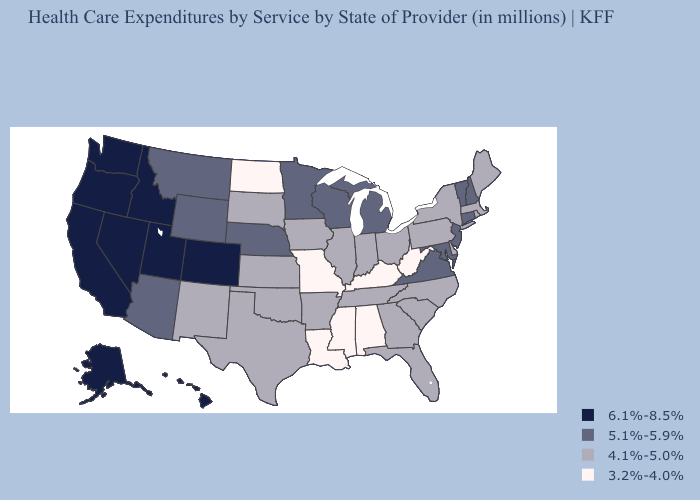Does Hawaii have a higher value than Washington?
Concise answer only. No. Among the states that border Minnesota , does South Dakota have the highest value?
Keep it brief. No. Name the states that have a value in the range 5.1%-5.9%?
Give a very brief answer. Arizona, Connecticut, Maryland, Michigan, Minnesota, Montana, Nebraska, New Hampshire, New Jersey, Vermont, Virginia, Wisconsin, Wyoming. Which states have the lowest value in the USA?
Concise answer only. Alabama, Kentucky, Louisiana, Mississippi, Missouri, North Dakota, West Virginia. What is the highest value in states that border Pennsylvania?
Short answer required. 5.1%-5.9%. Does the first symbol in the legend represent the smallest category?
Give a very brief answer. No. Among the states that border Maryland , does Virginia have the highest value?
Be succinct. Yes. What is the value of Alaska?
Short answer required. 6.1%-8.5%. Name the states that have a value in the range 4.1%-5.0%?
Write a very short answer. Arkansas, Delaware, Florida, Georgia, Illinois, Indiana, Iowa, Kansas, Maine, Massachusetts, New Mexico, New York, North Carolina, Ohio, Oklahoma, Pennsylvania, Rhode Island, South Carolina, South Dakota, Tennessee, Texas. Among the states that border California , does Arizona have the highest value?
Short answer required. No. What is the value of North Dakota?
Write a very short answer. 3.2%-4.0%. What is the value of Minnesota?
Be succinct. 5.1%-5.9%. Among the states that border Maryland , which have the lowest value?
Be succinct. West Virginia. Name the states that have a value in the range 5.1%-5.9%?
Short answer required. Arizona, Connecticut, Maryland, Michigan, Minnesota, Montana, Nebraska, New Hampshire, New Jersey, Vermont, Virginia, Wisconsin, Wyoming. Name the states that have a value in the range 5.1%-5.9%?
Concise answer only. Arizona, Connecticut, Maryland, Michigan, Minnesota, Montana, Nebraska, New Hampshire, New Jersey, Vermont, Virginia, Wisconsin, Wyoming. 